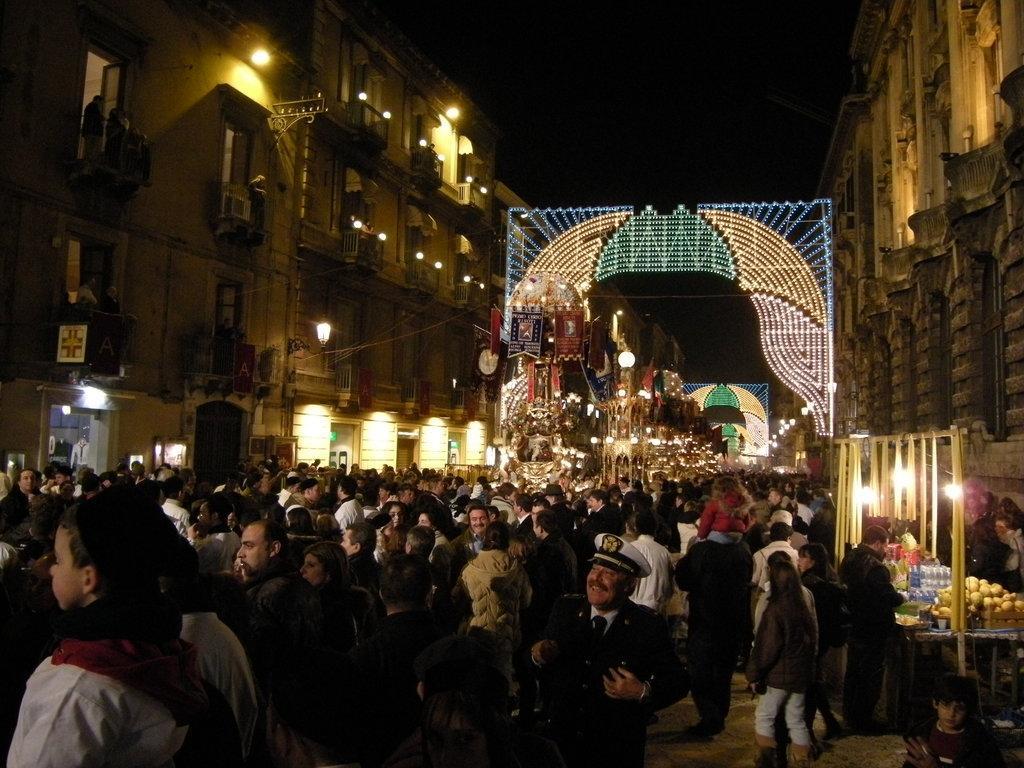Describe this image in one or two sentences. In this picture we can see a group of people on the ground, lights, bottles, buildings with windows, some objects and in the background it is dark. 